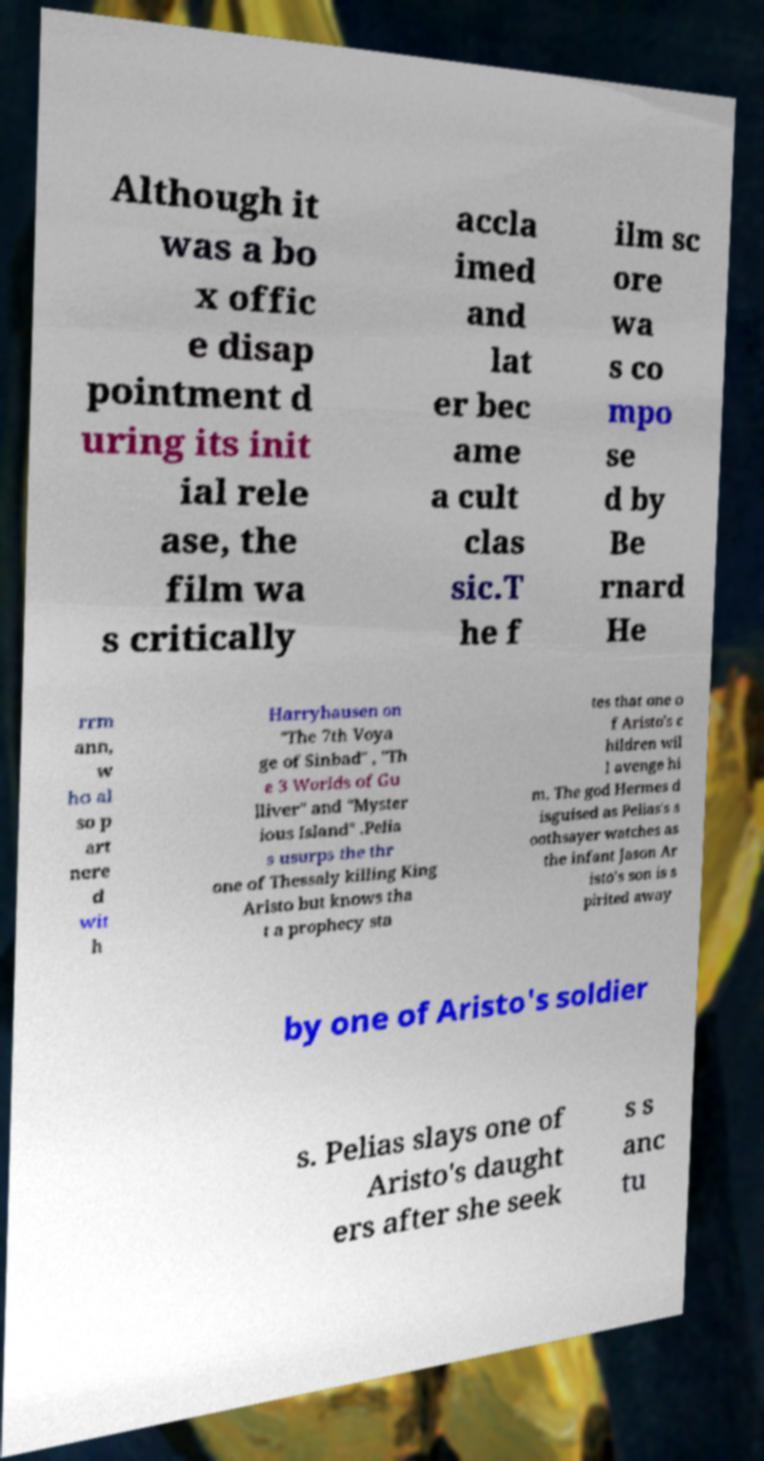Please read and relay the text visible in this image. What does it say? Although it was a bo x offic e disap pointment d uring its init ial rele ase, the film wa s critically accla imed and lat er bec ame a cult clas sic.T he f ilm sc ore wa s co mpo se d by Be rnard He rrm ann, w ho al so p art nere d wit h Harryhausen on "The 7th Voya ge of Sinbad" , "Th e 3 Worlds of Gu lliver" and "Myster ious Island" .Pelia s usurps the thr one of Thessaly killing King Aristo but knows tha t a prophecy sta tes that one o f Aristo's c hildren wil l avenge hi m. The god Hermes d isguised as Pelias's s oothsayer watches as the infant Jason Ar isto's son is s pirited away by one of Aristo's soldier s. Pelias slays one of Aristo's daught ers after she seek s s anc tu 